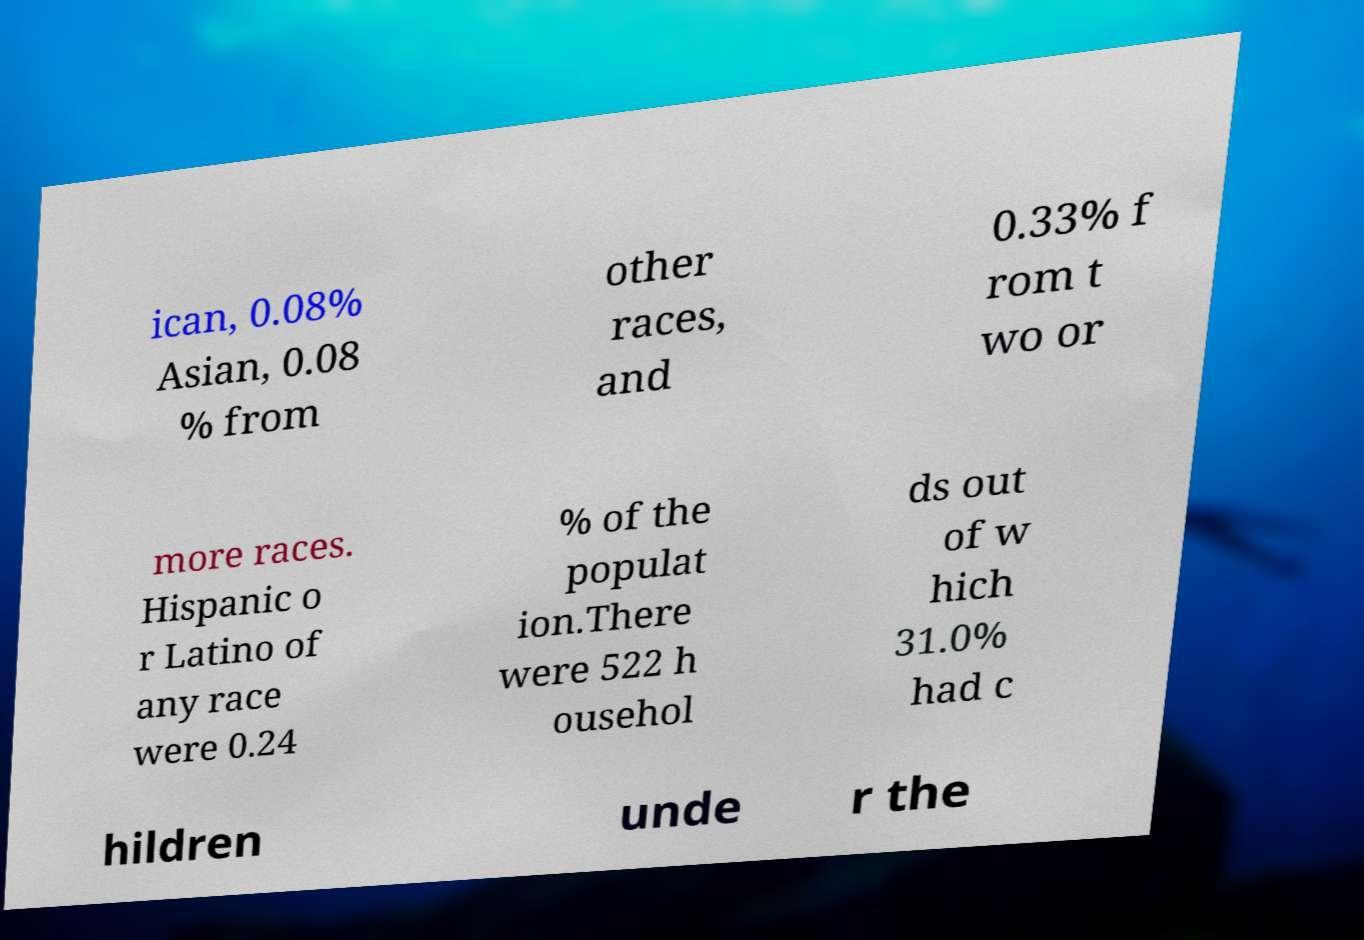For documentation purposes, I need the text within this image transcribed. Could you provide that? ican, 0.08% Asian, 0.08 % from other races, and 0.33% f rom t wo or more races. Hispanic o r Latino of any race were 0.24 % of the populat ion.There were 522 h ousehol ds out of w hich 31.0% had c hildren unde r the 